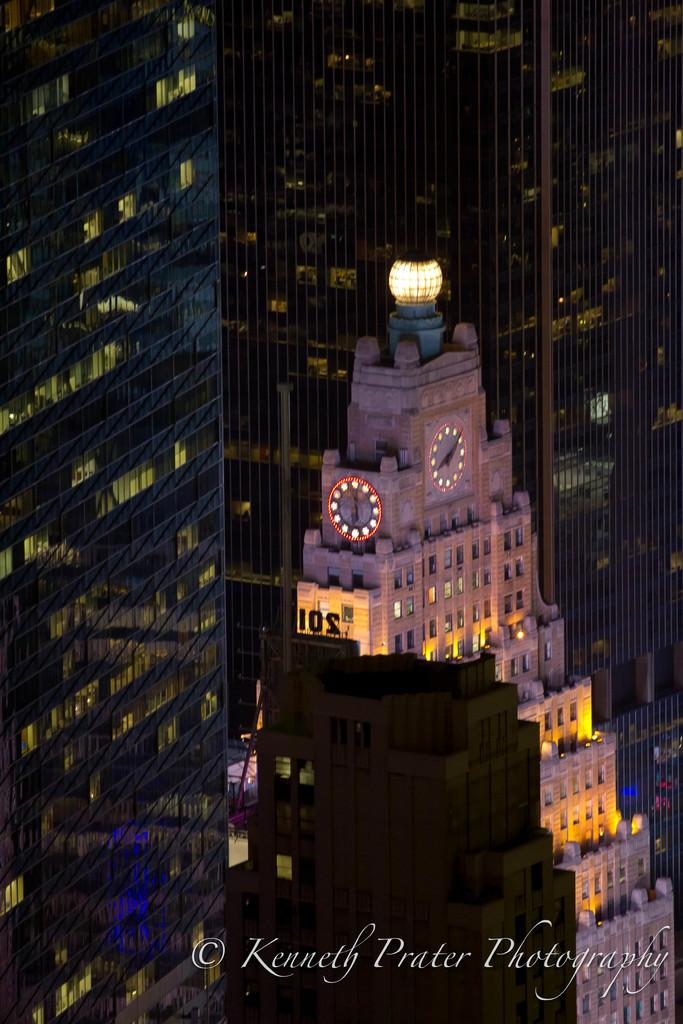What type of buildings are shown in the image? The buildings in the image have glass windows. How many clocks are on the wall in the image? There are two clocks on the wall in the image. Can you describe the lighting in the image? There is light visible in the image. Is there any text or marking at the bottom of the image? Yes, there is a watermark at the bottom of the image. What type of wine is being served at the table in the image? There is no table or wine present in the image; it features buildings with glass windows, clocks on the wall, light, and a watermark. 